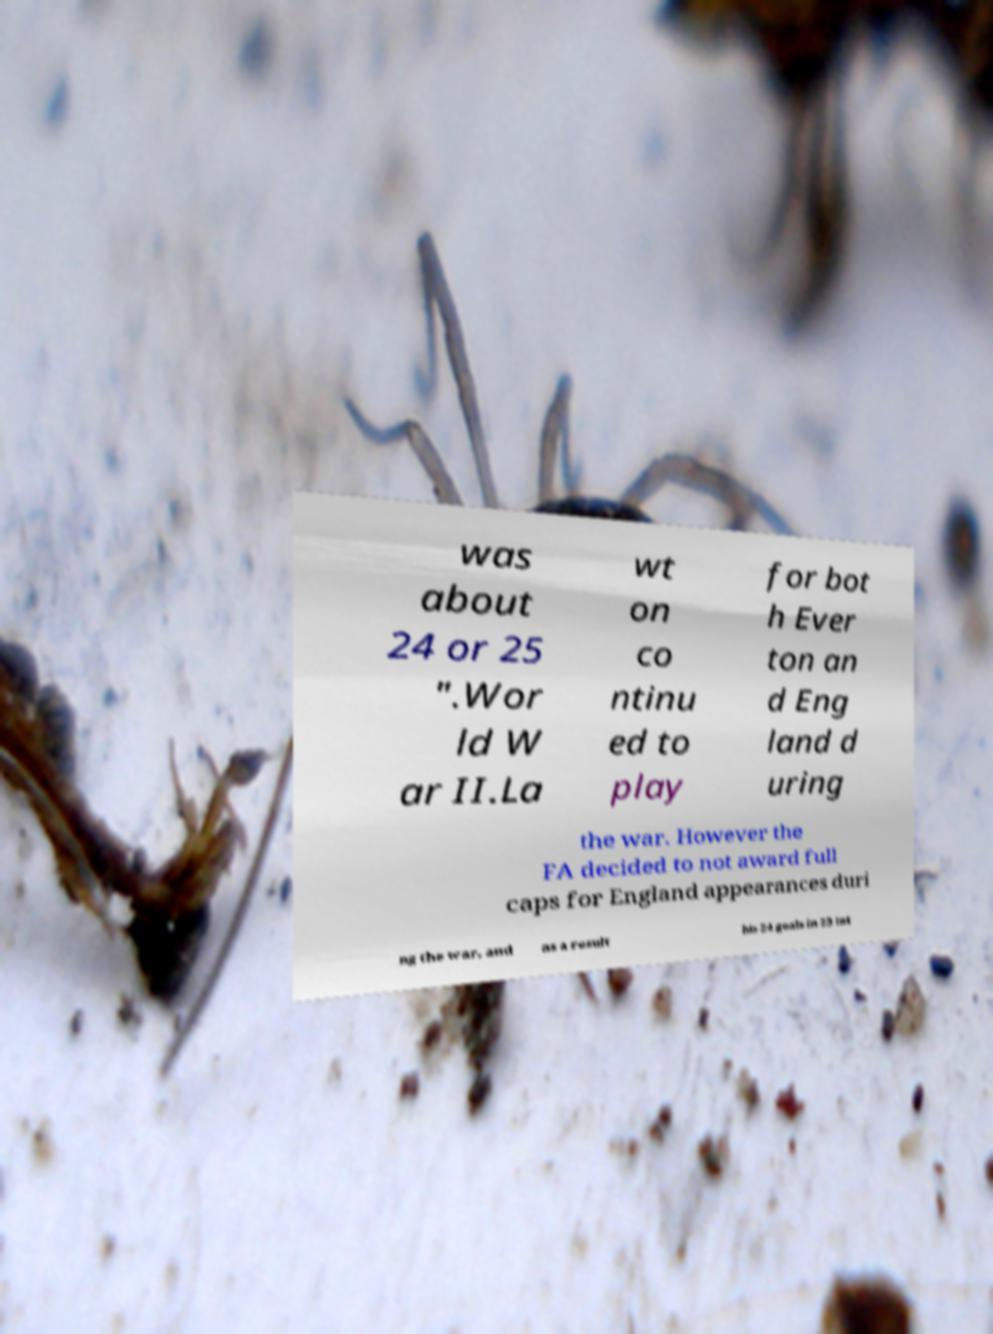Please read and relay the text visible in this image. What does it say? was about 24 or 25 ".Wor ld W ar II.La wt on co ntinu ed to play for bot h Ever ton an d Eng land d uring the war. However the FA decided to not award full caps for England appearances duri ng the war, and as a result his 24 goals in 23 int 